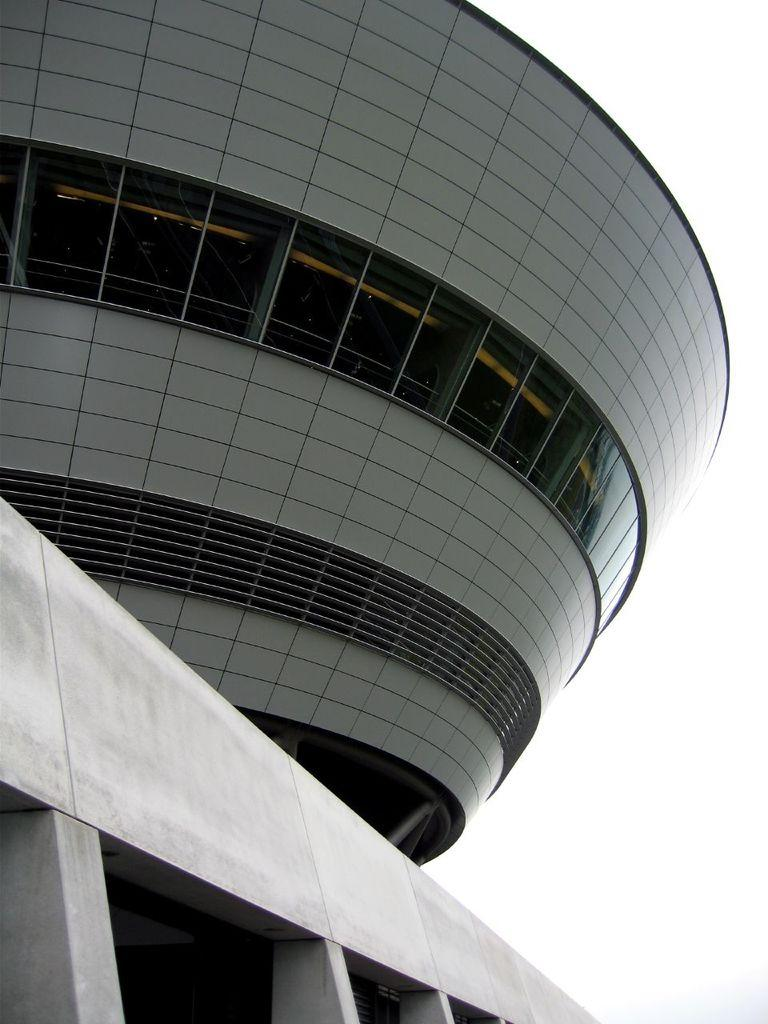What structure can be seen in the bottom left corner of the image? There is a pillar in the bottom left corner of the image. What is the main feature of the image? There is a big building in the image. What color is the background of the image? The background of the image is white in color. Can you see a river flowing in the background of the image? There is no river present in the image; the background is white in color. Is there a kettle visible on the pillar in the image? There is no kettle present in the image; only a pillar and a big building are visible. 